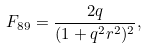<formula> <loc_0><loc_0><loc_500><loc_500>F _ { 8 9 } = \frac { 2 q } { ( 1 + q ^ { 2 } r ^ { 2 } ) ^ { 2 } } ,</formula> 